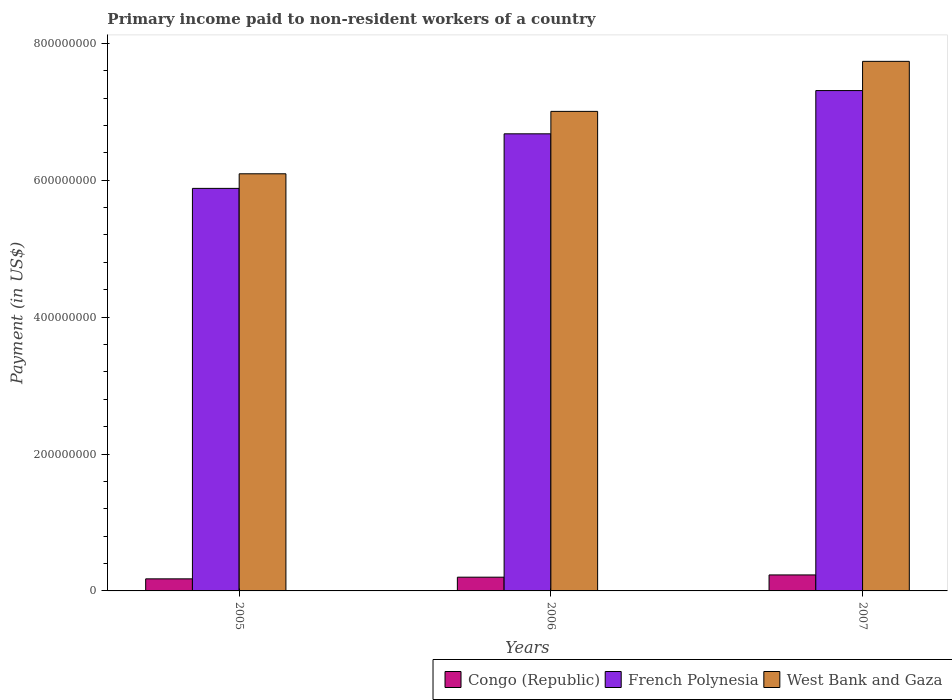How many different coloured bars are there?
Ensure brevity in your answer.  3. Are the number of bars per tick equal to the number of legend labels?
Provide a succinct answer. Yes. Are the number of bars on each tick of the X-axis equal?
Your answer should be very brief. Yes. What is the label of the 1st group of bars from the left?
Keep it short and to the point. 2005. In how many cases, is the number of bars for a given year not equal to the number of legend labels?
Give a very brief answer. 0. What is the amount paid to workers in Congo (Republic) in 2007?
Make the answer very short. 2.34e+07. Across all years, what is the maximum amount paid to workers in French Polynesia?
Ensure brevity in your answer.  7.31e+08. Across all years, what is the minimum amount paid to workers in Congo (Republic)?
Offer a terse response. 1.76e+07. In which year was the amount paid to workers in Congo (Republic) maximum?
Your answer should be very brief. 2007. In which year was the amount paid to workers in French Polynesia minimum?
Your answer should be very brief. 2005. What is the total amount paid to workers in Congo (Republic) in the graph?
Your answer should be compact. 6.11e+07. What is the difference between the amount paid to workers in Congo (Republic) in 2006 and that in 2007?
Provide a short and direct response. -3.29e+06. What is the difference between the amount paid to workers in West Bank and Gaza in 2007 and the amount paid to workers in French Polynesia in 2005?
Offer a terse response. 1.86e+08. What is the average amount paid to workers in West Bank and Gaza per year?
Your response must be concise. 6.95e+08. In the year 2005, what is the difference between the amount paid to workers in French Polynesia and amount paid to workers in Congo (Republic)?
Offer a very short reply. 5.70e+08. In how many years, is the amount paid to workers in French Polynesia greater than 440000000 US$?
Offer a very short reply. 3. What is the ratio of the amount paid to workers in Congo (Republic) in 2005 to that in 2006?
Your response must be concise. 0.88. Is the amount paid to workers in Congo (Republic) in 2005 less than that in 2007?
Make the answer very short. Yes. Is the difference between the amount paid to workers in French Polynesia in 2005 and 2007 greater than the difference between the amount paid to workers in Congo (Republic) in 2005 and 2007?
Your answer should be very brief. No. What is the difference between the highest and the second highest amount paid to workers in Congo (Republic)?
Keep it short and to the point. 3.29e+06. What is the difference between the highest and the lowest amount paid to workers in French Polynesia?
Give a very brief answer. 1.43e+08. In how many years, is the amount paid to workers in West Bank and Gaza greater than the average amount paid to workers in West Bank and Gaza taken over all years?
Ensure brevity in your answer.  2. Is the sum of the amount paid to workers in Congo (Republic) in 2006 and 2007 greater than the maximum amount paid to workers in French Polynesia across all years?
Offer a terse response. No. What does the 2nd bar from the left in 2005 represents?
Offer a very short reply. French Polynesia. What does the 3rd bar from the right in 2005 represents?
Offer a terse response. Congo (Republic). Is it the case that in every year, the sum of the amount paid to workers in West Bank and Gaza and amount paid to workers in French Polynesia is greater than the amount paid to workers in Congo (Republic)?
Offer a very short reply. Yes. How many bars are there?
Ensure brevity in your answer.  9. What is the difference between two consecutive major ticks on the Y-axis?
Offer a terse response. 2.00e+08. What is the title of the graph?
Keep it short and to the point. Primary income paid to non-resident workers of a country. Does "Algeria" appear as one of the legend labels in the graph?
Your response must be concise. No. What is the label or title of the Y-axis?
Provide a succinct answer. Payment (in US$). What is the Payment (in US$) in Congo (Republic) in 2005?
Keep it short and to the point. 1.76e+07. What is the Payment (in US$) of French Polynesia in 2005?
Provide a short and direct response. 5.88e+08. What is the Payment (in US$) in West Bank and Gaza in 2005?
Provide a short and direct response. 6.09e+08. What is the Payment (in US$) in Congo (Republic) in 2006?
Give a very brief answer. 2.01e+07. What is the Payment (in US$) of French Polynesia in 2006?
Your response must be concise. 6.68e+08. What is the Payment (in US$) in West Bank and Gaza in 2006?
Give a very brief answer. 7.01e+08. What is the Payment (in US$) of Congo (Republic) in 2007?
Your answer should be very brief. 2.34e+07. What is the Payment (in US$) in French Polynesia in 2007?
Give a very brief answer. 7.31e+08. What is the Payment (in US$) in West Bank and Gaza in 2007?
Provide a succinct answer. 7.74e+08. Across all years, what is the maximum Payment (in US$) in Congo (Republic)?
Provide a short and direct response. 2.34e+07. Across all years, what is the maximum Payment (in US$) in French Polynesia?
Ensure brevity in your answer.  7.31e+08. Across all years, what is the maximum Payment (in US$) of West Bank and Gaza?
Your response must be concise. 7.74e+08. Across all years, what is the minimum Payment (in US$) of Congo (Republic)?
Your answer should be very brief. 1.76e+07. Across all years, what is the minimum Payment (in US$) in French Polynesia?
Provide a short and direct response. 5.88e+08. Across all years, what is the minimum Payment (in US$) in West Bank and Gaza?
Offer a terse response. 6.09e+08. What is the total Payment (in US$) of Congo (Republic) in the graph?
Provide a short and direct response. 6.11e+07. What is the total Payment (in US$) in French Polynesia in the graph?
Give a very brief answer. 1.99e+09. What is the total Payment (in US$) of West Bank and Gaza in the graph?
Provide a short and direct response. 2.08e+09. What is the difference between the Payment (in US$) in Congo (Republic) in 2005 and that in 2006?
Make the answer very short. -2.45e+06. What is the difference between the Payment (in US$) of French Polynesia in 2005 and that in 2006?
Provide a short and direct response. -7.97e+07. What is the difference between the Payment (in US$) of West Bank and Gaza in 2005 and that in 2006?
Keep it short and to the point. -9.12e+07. What is the difference between the Payment (in US$) of Congo (Republic) in 2005 and that in 2007?
Your answer should be very brief. -5.74e+06. What is the difference between the Payment (in US$) in French Polynesia in 2005 and that in 2007?
Provide a succinct answer. -1.43e+08. What is the difference between the Payment (in US$) of West Bank and Gaza in 2005 and that in 2007?
Your answer should be very brief. -1.64e+08. What is the difference between the Payment (in US$) of Congo (Republic) in 2006 and that in 2007?
Your response must be concise. -3.29e+06. What is the difference between the Payment (in US$) in French Polynesia in 2006 and that in 2007?
Ensure brevity in your answer.  -6.32e+07. What is the difference between the Payment (in US$) of West Bank and Gaza in 2006 and that in 2007?
Your answer should be compact. -7.31e+07. What is the difference between the Payment (in US$) in Congo (Republic) in 2005 and the Payment (in US$) in French Polynesia in 2006?
Your response must be concise. -6.50e+08. What is the difference between the Payment (in US$) in Congo (Republic) in 2005 and the Payment (in US$) in West Bank and Gaza in 2006?
Your response must be concise. -6.83e+08. What is the difference between the Payment (in US$) in French Polynesia in 2005 and the Payment (in US$) in West Bank and Gaza in 2006?
Give a very brief answer. -1.12e+08. What is the difference between the Payment (in US$) of Congo (Republic) in 2005 and the Payment (in US$) of French Polynesia in 2007?
Give a very brief answer. -7.13e+08. What is the difference between the Payment (in US$) of Congo (Republic) in 2005 and the Payment (in US$) of West Bank and Gaza in 2007?
Your answer should be compact. -7.56e+08. What is the difference between the Payment (in US$) in French Polynesia in 2005 and the Payment (in US$) in West Bank and Gaza in 2007?
Provide a succinct answer. -1.86e+08. What is the difference between the Payment (in US$) in Congo (Republic) in 2006 and the Payment (in US$) in French Polynesia in 2007?
Keep it short and to the point. -7.11e+08. What is the difference between the Payment (in US$) in Congo (Republic) in 2006 and the Payment (in US$) in West Bank and Gaza in 2007?
Provide a short and direct response. -7.54e+08. What is the difference between the Payment (in US$) in French Polynesia in 2006 and the Payment (in US$) in West Bank and Gaza in 2007?
Offer a very short reply. -1.06e+08. What is the average Payment (in US$) in Congo (Republic) per year?
Offer a terse response. 2.04e+07. What is the average Payment (in US$) of French Polynesia per year?
Offer a very short reply. 6.62e+08. What is the average Payment (in US$) of West Bank and Gaza per year?
Keep it short and to the point. 6.95e+08. In the year 2005, what is the difference between the Payment (in US$) of Congo (Republic) and Payment (in US$) of French Polynesia?
Your response must be concise. -5.70e+08. In the year 2005, what is the difference between the Payment (in US$) in Congo (Republic) and Payment (in US$) in West Bank and Gaza?
Your answer should be very brief. -5.92e+08. In the year 2005, what is the difference between the Payment (in US$) in French Polynesia and Payment (in US$) in West Bank and Gaza?
Make the answer very short. -2.13e+07. In the year 2006, what is the difference between the Payment (in US$) of Congo (Republic) and Payment (in US$) of French Polynesia?
Give a very brief answer. -6.48e+08. In the year 2006, what is the difference between the Payment (in US$) of Congo (Republic) and Payment (in US$) of West Bank and Gaza?
Ensure brevity in your answer.  -6.80e+08. In the year 2006, what is the difference between the Payment (in US$) in French Polynesia and Payment (in US$) in West Bank and Gaza?
Provide a short and direct response. -3.28e+07. In the year 2007, what is the difference between the Payment (in US$) of Congo (Republic) and Payment (in US$) of French Polynesia?
Your response must be concise. -7.08e+08. In the year 2007, what is the difference between the Payment (in US$) in Congo (Republic) and Payment (in US$) in West Bank and Gaza?
Your response must be concise. -7.50e+08. In the year 2007, what is the difference between the Payment (in US$) of French Polynesia and Payment (in US$) of West Bank and Gaza?
Make the answer very short. -4.27e+07. What is the ratio of the Payment (in US$) in Congo (Republic) in 2005 to that in 2006?
Your response must be concise. 0.88. What is the ratio of the Payment (in US$) in French Polynesia in 2005 to that in 2006?
Provide a short and direct response. 0.88. What is the ratio of the Payment (in US$) in West Bank and Gaza in 2005 to that in 2006?
Provide a short and direct response. 0.87. What is the ratio of the Payment (in US$) of Congo (Republic) in 2005 to that in 2007?
Keep it short and to the point. 0.75. What is the ratio of the Payment (in US$) in French Polynesia in 2005 to that in 2007?
Offer a very short reply. 0.8. What is the ratio of the Payment (in US$) in West Bank and Gaza in 2005 to that in 2007?
Offer a terse response. 0.79. What is the ratio of the Payment (in US$) of Congo (Republic) in 2006 to that in 2007?
Give a very brief answer. 0.86. What is the ratio of the Payment (in US$) of French Polynesia in 2006 to that in 2007?
Make the answer very short. 0.91. What is the ratio of the Payment (in US$) of West Bank and Gaza in 2006 to that in 2007?
Make the answer very short. 0.91. What is the difference between the highest and the second highest Payment (in US$) of Congo (Republic)?
Ensure brevity in your answer.  3.29e+06. What is the difference between the highest and the second highest Payment (in US$) of French Polynesia?
Provide a succinct answer. 6.32e+07. What is the difference between the highest and the second highest Payment (in US$) in West Bank and Gaza?
Offer a very short reply. 7.31e+07. What is the difference between the highest and the lowest Payment (in US$) in Congo (Republic)?
Offer a very short reply. 5.74e+06. What is the difference between the highest and the lowest Payment (in US$) of French Polynesia?
Your answer should be compact. 1.43e+08. What is the difference between the highest and the lowest Payment (in US$) of West Bank and Gaza?
Keep it short and to the point. 1.64e+08. 